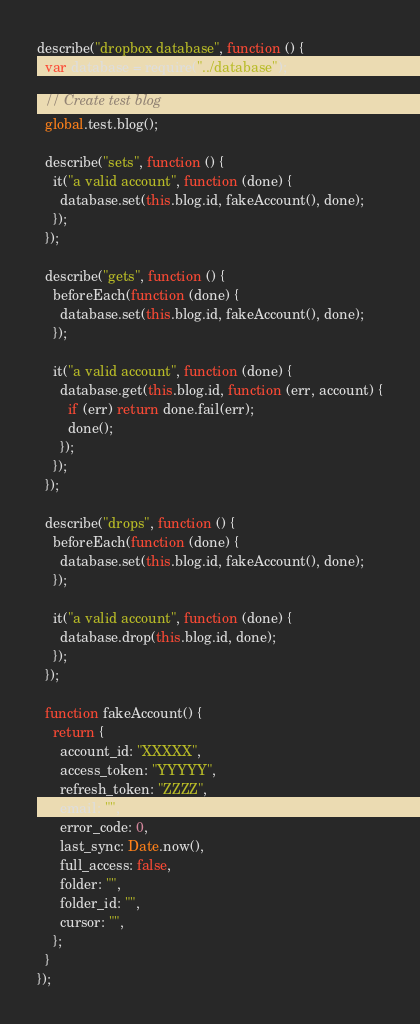Convert code to text. <code><loc_0><loc_0><loc_500><loc_500><_JavaScript_>describe("dropbox database", function () {
  var database = require("../database");

  // Create test blog
  global.test.blog();

  describe("sets", function () {
    it("a valid account", function (done) {
      database.set(this.blog.id, fakeAccount(), done);
    });
  });

  describe("gets", function () {
    beforeEach(function (done) {
      database.set(this.blog.id, fakeAccount(), done);
    });

    it("a valid account", function (done) {
      database.get(this.blog.id, function (err, account) {
        if (err) return done.fail(err);
        done();
      });
    });
  });

  describe("drops", function () {
    beforeEach(function (done) {
      database.set(this.blog.id, fakeAccount(), done);
    });

    it("a valid account", function (done) {
      database.drop(this.blog.id, done);
    });
  });

  function fakeAccount() {
    return {
      account_id: "XXXXX",
      access_token: "YYYYY",
      refresh_token: "ZZZZ",
      email: "",
      error_code: 0,
      last_sync: Date.now(),
      full_access: false,
      folder: "",
      folder_id: "",
      cursor: "",
    };
  }
});
</code> 